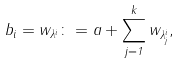<formula> <loc_0><loc_0><loc_500><loc_500>b _ { i } = w _ { \lambda ^ { i } } \colon = a + \sum _ { j = 1 } ^ { k } w _ { \lambda _ { j } ^ { i } } ,</formula> 